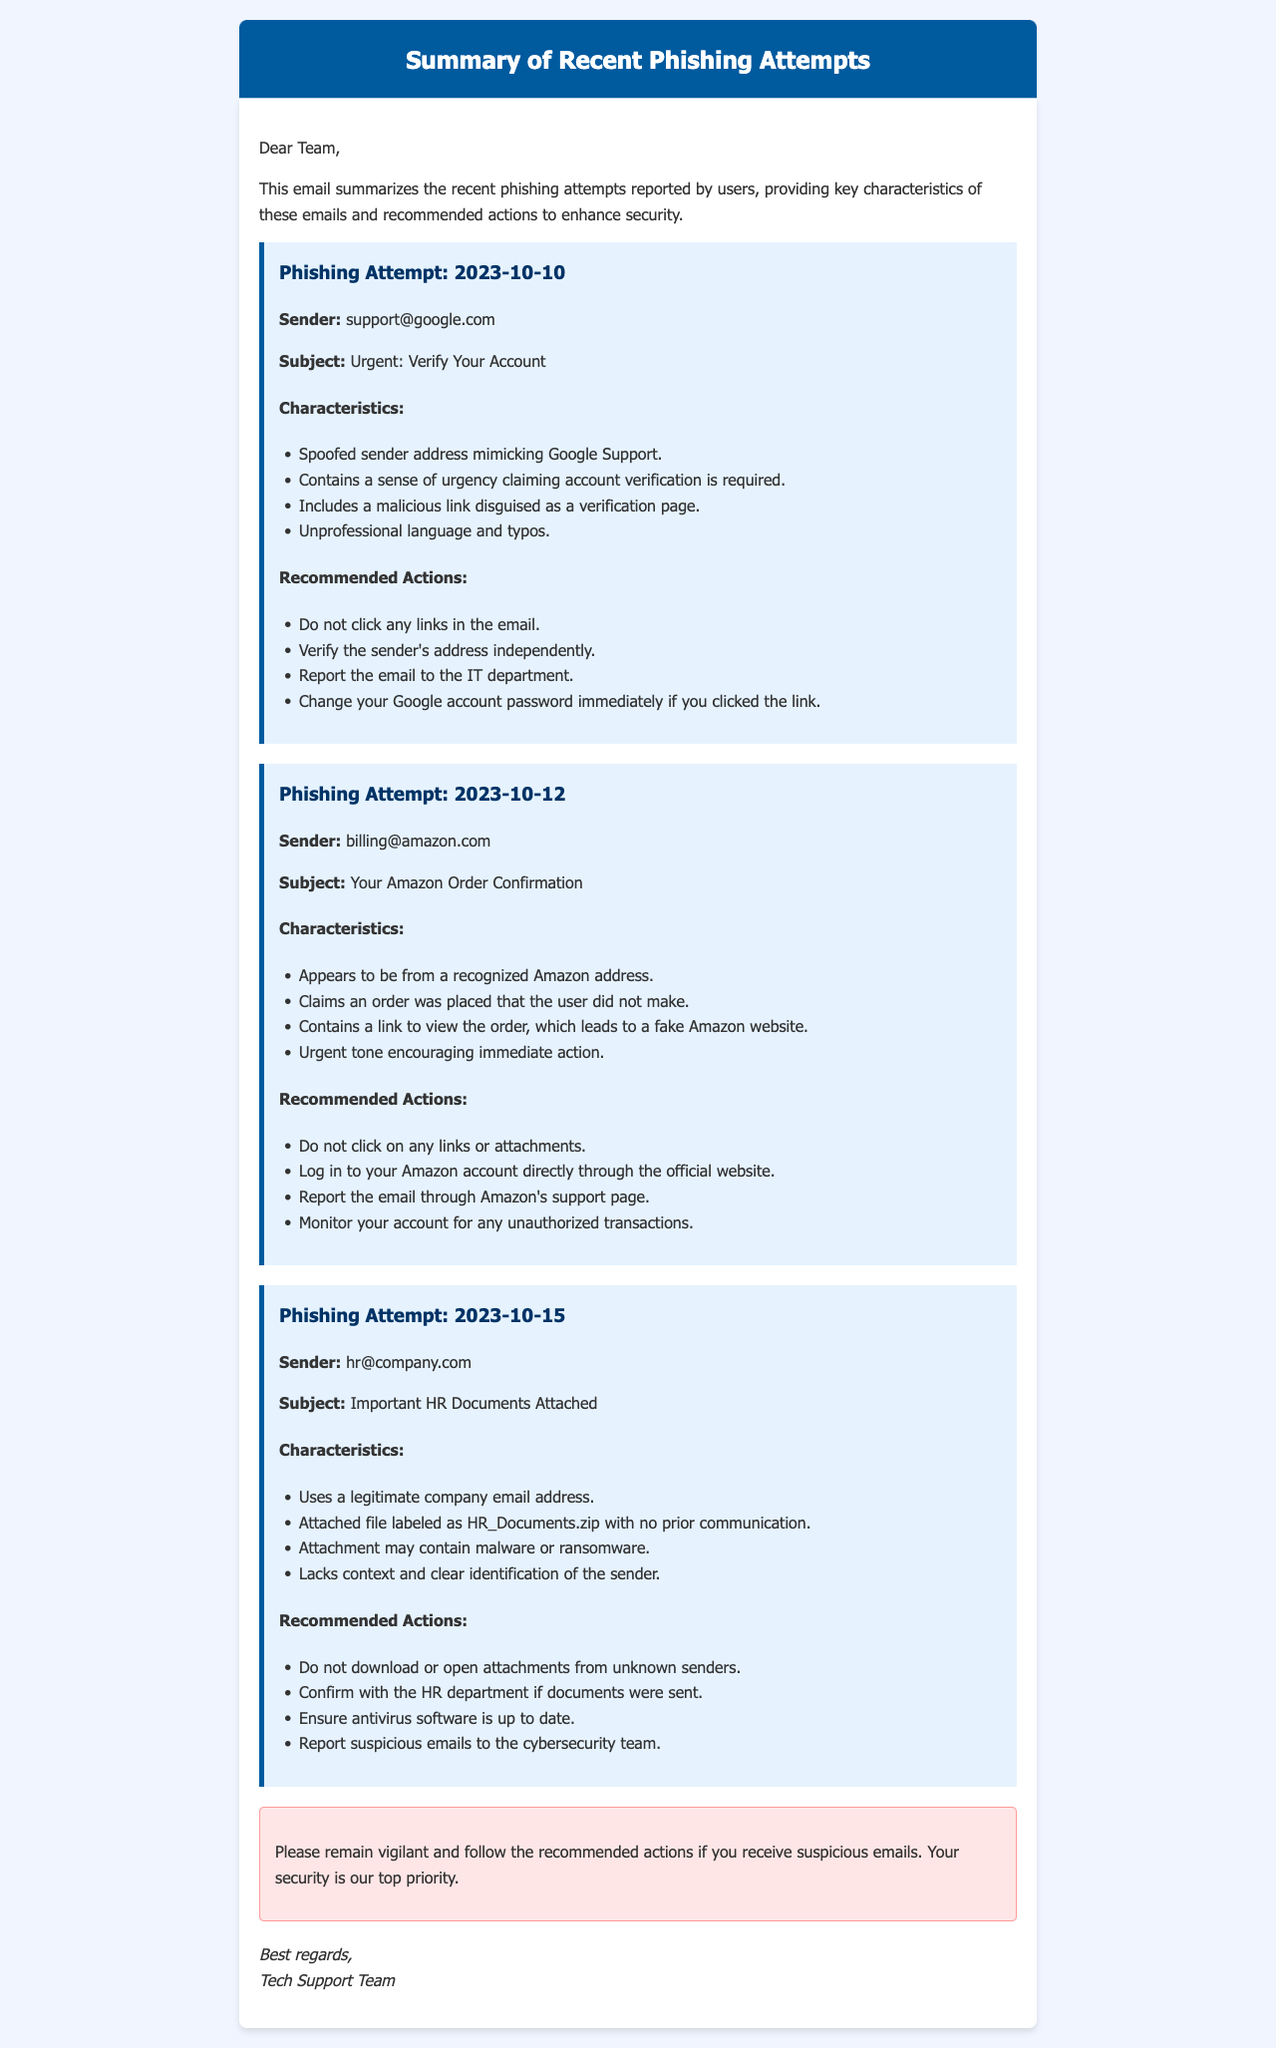What is the date of the first phishing attempt reported? The first phishing attempt in the document is mentioned as occurring on October 10, 2023.
Answer: 2023-10-10 What is the email subject of the phishing attempt from Amazon? The email subject pertaining to the phishing attempt from Amazon is listed as "Your Amazon Order Confirmation."
Answer: Your Amazon Order Confirmation Which department should you report suspect emails to if they contain attachments? The document advises to report suspicious emails to the cybersecurity team.
Answer: cybersecurity team What type of malicious content may the attachment in the phishing attempt from HR contain? It is stated that the attachment might contain malware or ransomware.
Answer: malware or ransomware What action should be taken if a link from a phishing email is clicked? Users are advised to change their Google account password immediately if they clicked on a link from the phishing email.
Answer: Change your Google account password immediately How many phishing attempts are summarized in the document? The document summarizes a total of three phishing attempts.
Answer: three What is a common characteristic of the phishing attempts mentioned? A common characteristic is the use of urgency, where the emails claim immediate action is required.
Answer: Urgency What should users do with any links in the phishing email from Google Support? Users should not click any links in the email from Google Support.
Answer: Do not click any links in the email 